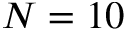Convert formula to latex. <formula><loc_0><loc_0><loc_500><loc_500>N = 1 0</formula> 